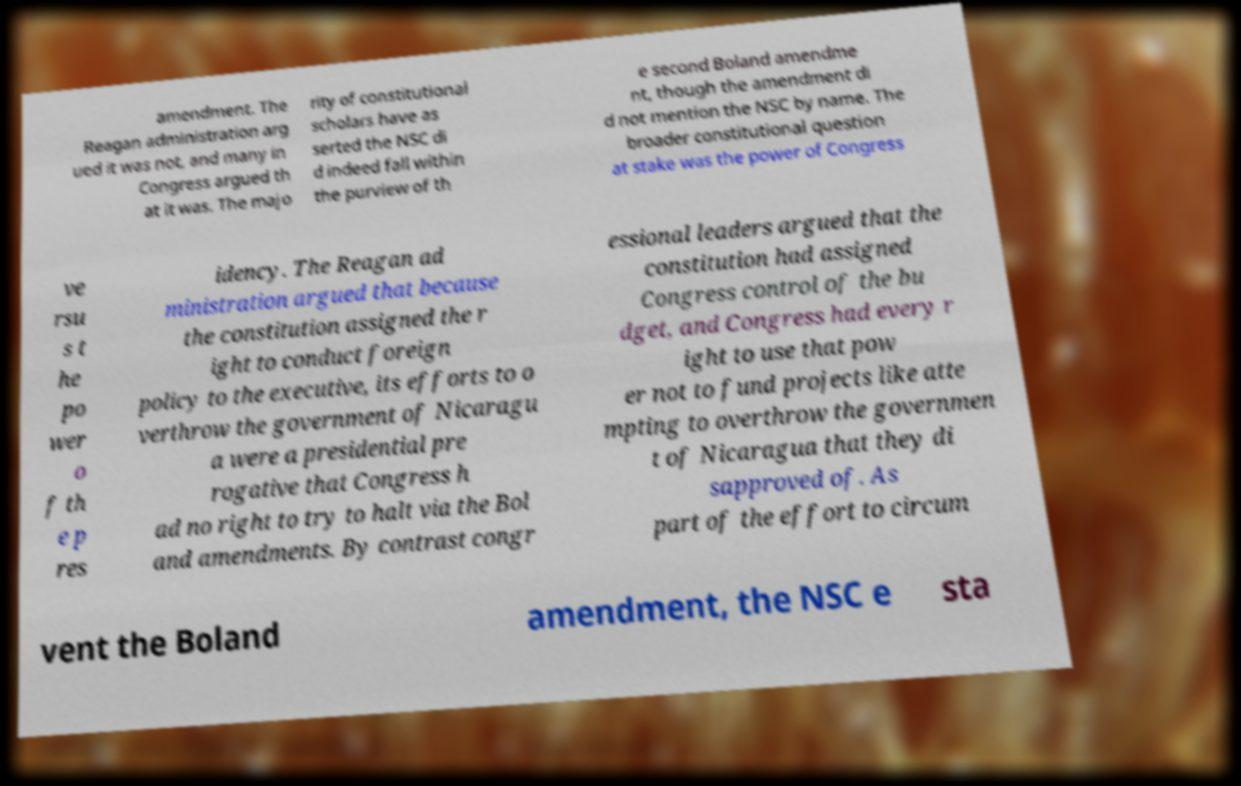I need the written content from this picture converted into text. Can you do that? amendment. The Reagan administration arg ued it was not, and many in Congress argued th at it was. The majo rity of constitutional scholars have as serted the NSC di d indeed fall within the purview of th e second Boland amendme nt, though the amendment di d not mention the NSC by name. The broader constitutional question at stake was the power of Congress ve rsu s t he po wer o f th e p res idency. The Reagan ad ministration argued that because the constitution assigned the r ight to conduct foreign policy to the executive, its efforts to o verthrow the government of Nicaragu a were a presidential pre rogative that Congress h ad no right to try to halt via the Bol and amendments. By contrast congr essional leaders argued that the constitution had assigned Congress control of the bu dget, and Congress had every r ight to use that pow er not to fund projects like atte mpting to overthrow the governmen t of Nicaragua that they di sapproved of. As part of the effort to circum vent the Boland amendment, the NSC e sta 